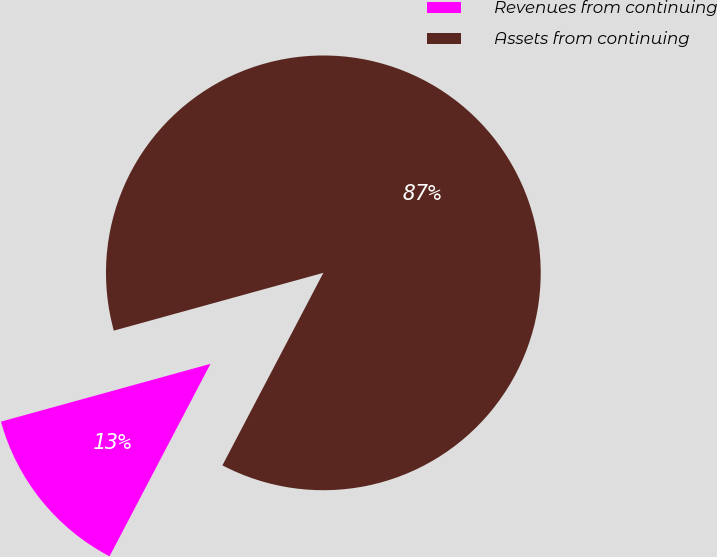Convert chart. <chart><loc_0><loc_0><loc_500><loc_500><pie_chart><fcel>Revenues from continuing<fcel>Assets from continuing<nl><fcel>13.03%<fcel>86.97%<nl></chart> 